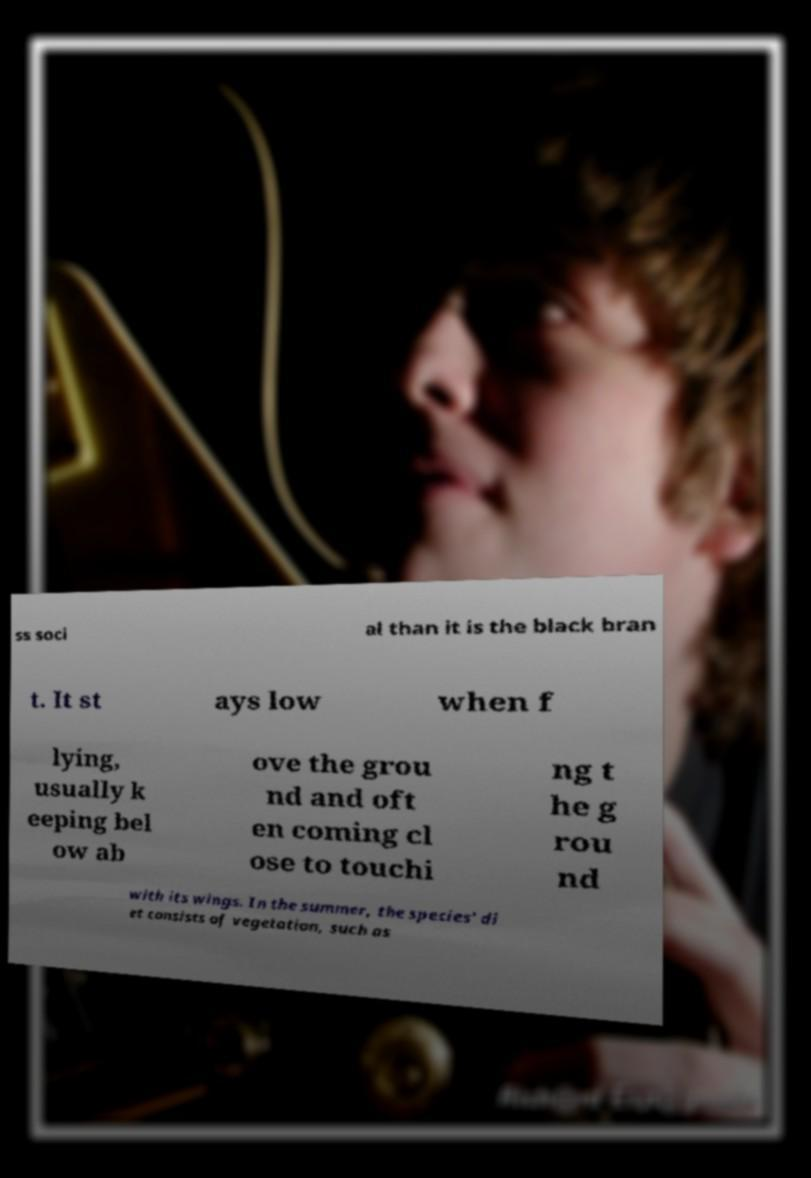Can you read and provide the text displayed in the image?This photo seems to have some interesting text. Can you extract and type it out for me? ss soci al than it is the black bran t. It st ays low when f lying, usually k eeping bel ow ab ove the grou nd and oft en coming cl ose to touchi ng t he g rou nd with its wings. In the summer, the species' di et consists of vegetation, such as 